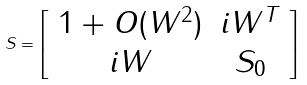Convert formula to latex. <formula><loc_0><loc_0><loc_500><loc_500>S = \left [ \begin{array} { c c } 1 + O ( W ^ { 2 } ) & i W ^ { T } \\ i W & S _ { 0 } \end{array} \right ]</formula> 